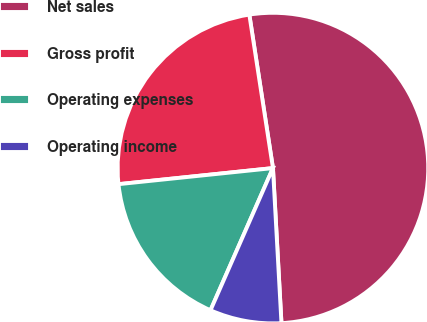Convert chart. <chart><loc_0><loc_0><loc_500><loc_500><pie_chart><fcel>Net sales<fcel>Gross profit<fcel>Operating expenses<fcel>Operating income<nl><fcel>51.56%<fcel>24.22%<fcel>16.76%<fcel>7.46%<nl></chart> 